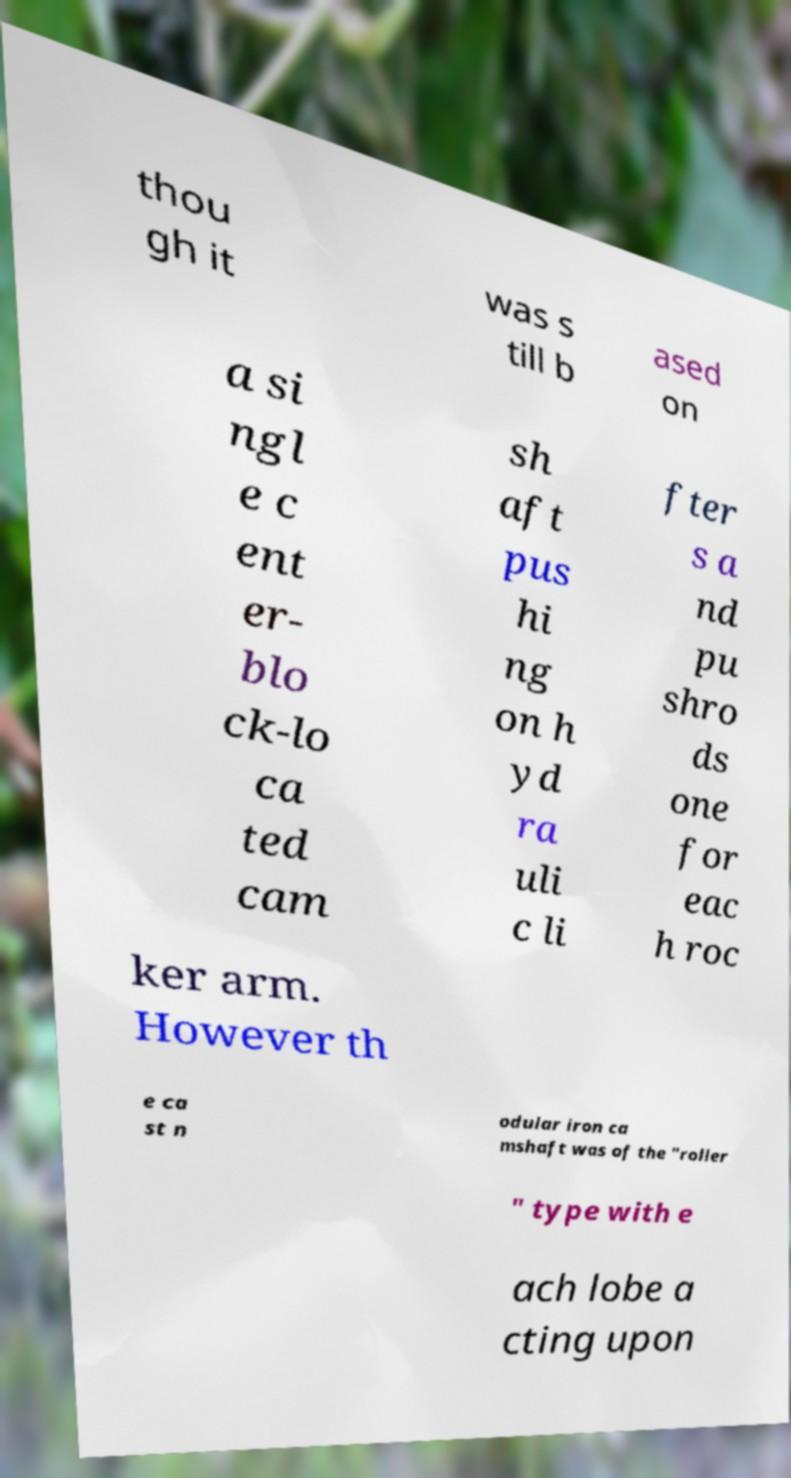Could you extract and type out the text from this image? thou gh it was s till b ased on a si ngl e c ent er- blo ck-lo ca ted cam sh aft pus hi ng on h yd ra uli c li fter s a nd pu shro ds one for eac h roc ker arm. However th e ca st n odular iron ca mshaft was of the "roller " type with e ach lobe a cting upon 